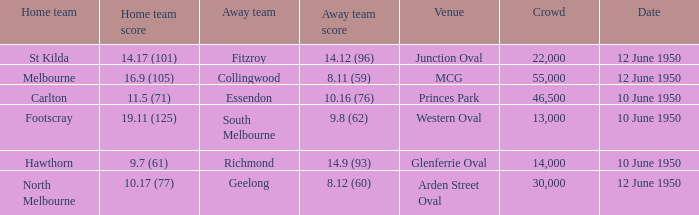What was the crowd when Melbourne was the home team? 55000.0. 